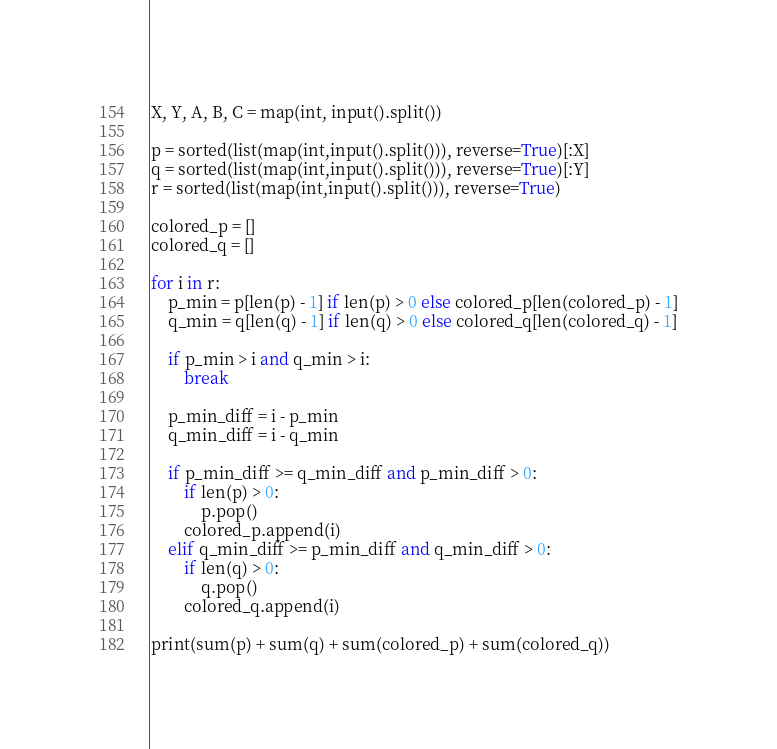<code> <loc_0><loc_0><loc_500><loc_500><_Python_>X, Y, A, B, C = map(int, input().split())
 
p = sorted(list(map(int,input().split())), reverse=True)[:X]
q = sorted(list(map(int,input().split())), reverse=True)[:Y]
r = sorted(list(map(int,input().split())), reverse=True)
 
colored_p = []
colored_q = []
 
for i in r:
    p_min = p[len(p) - 1] if len(p) > 0 else colored_p[len(colored_p) - 1]
    q_min = q[len(q) - 1] if len(q) > 0 else colored_q[len(colored_q) - 1]
 
    if p_min > i and q_min > i:
        break
 
    p_min_diff = i - p_min
    q_min_diff = i - q_min
 
    if p_min_diff >= q_min_diff and p_min_diff > 0:
        if len(p) > 0:
            p.pop()
        colored_p.append(i)
    elif q_min_diff >= p_min_diff and q_min_diff > 0:
        if len(q) > 0:
            q.pop()
        colored_q.append(i)
 
print(sum(p) + sum(q) + sum(colored_p) + sum(colored_q))</code> 